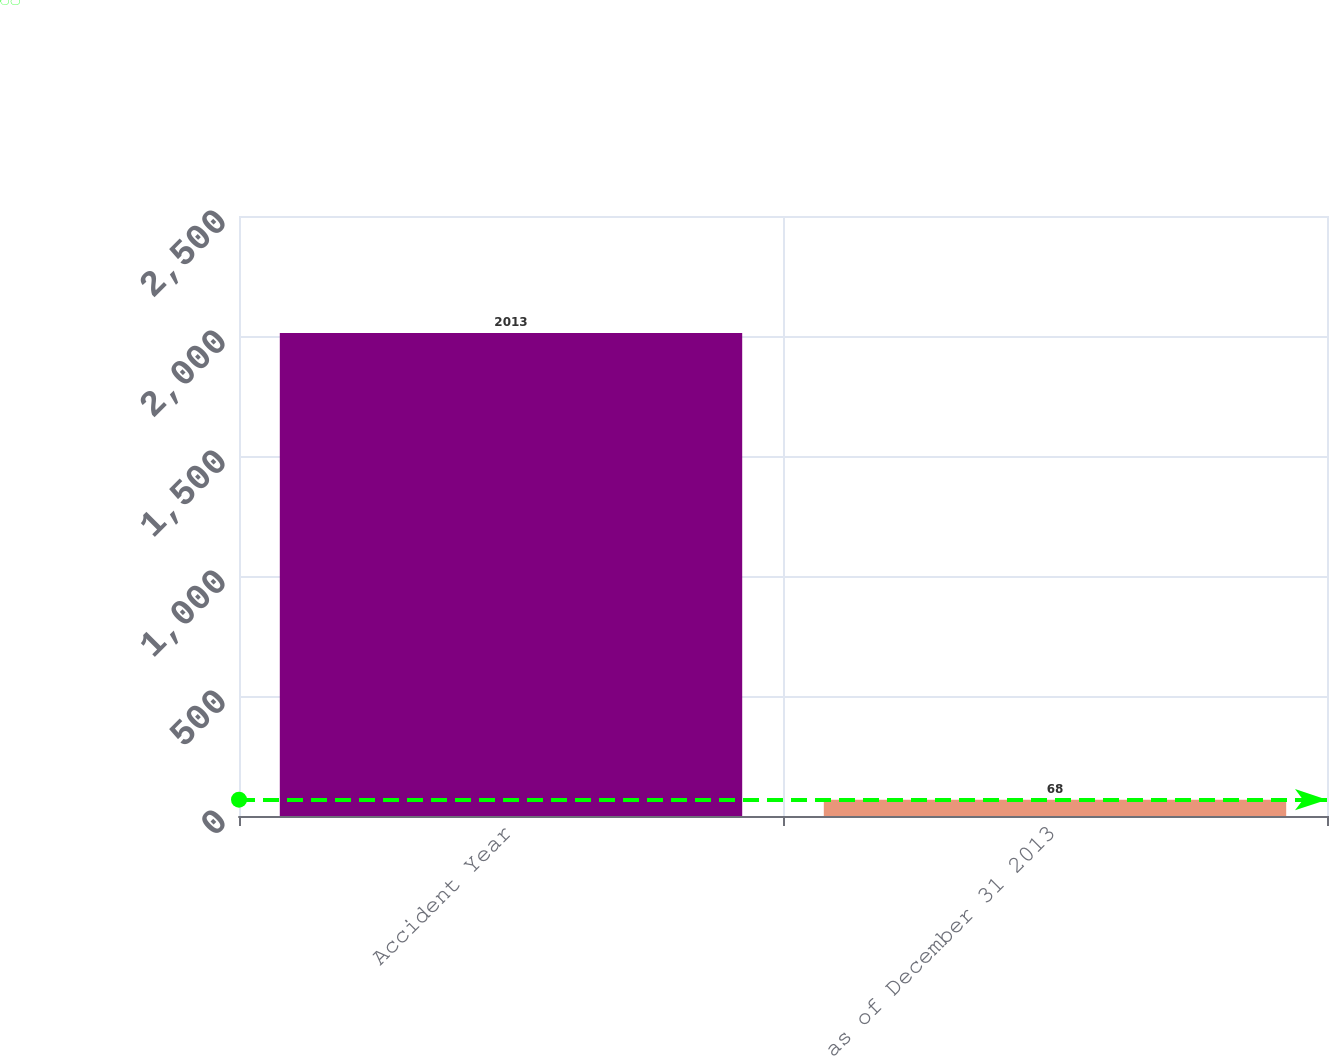Convert chart. <chart><loc_0><loc_0><loc_500><loc_500><bar_chart><fcel>Accident Year<fcel>as of December 31 2013<nl><fcel>2013<fcel>68<nl></chart> 